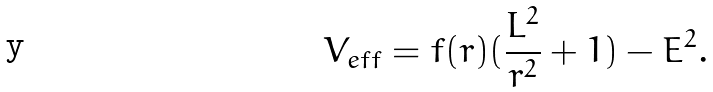<formula> <loc_0><loc_0><loc_500><loc_500>V _ { e f f } = f ( r ) ( \frac { L ^ { 2 } } { r ^ { 2 } } + 1 ) - E ^ { 2 } .</formula> 